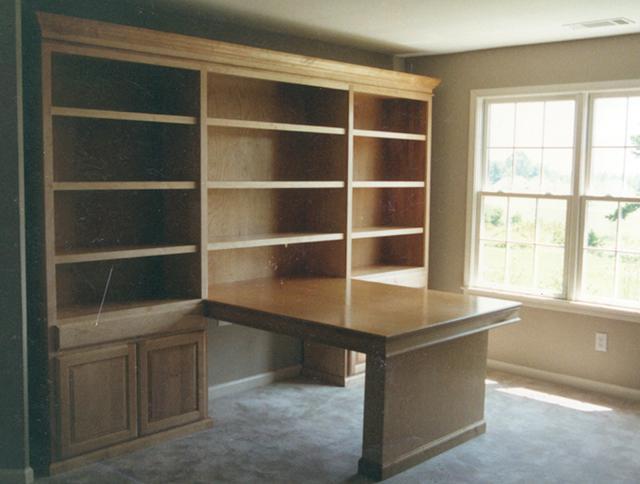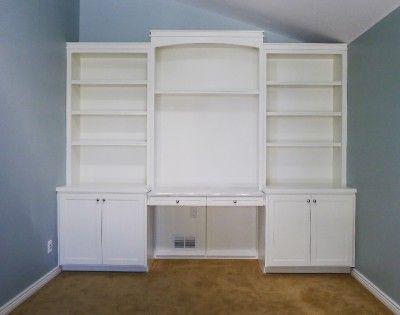The first image is the image on the left, the second image is the image on the right. Given the left and right images, does the statement "In one of the images, there are built in bookcases attached to a bright orange wall." hold true? Answer yes or no. No. The first image is the image on the left, the second image is the image on the right. For the images displayed, is the sentence "An image shows a white bookcase unit in front of a bright orange divider wall." factually correct? Answer yes or no. No. 